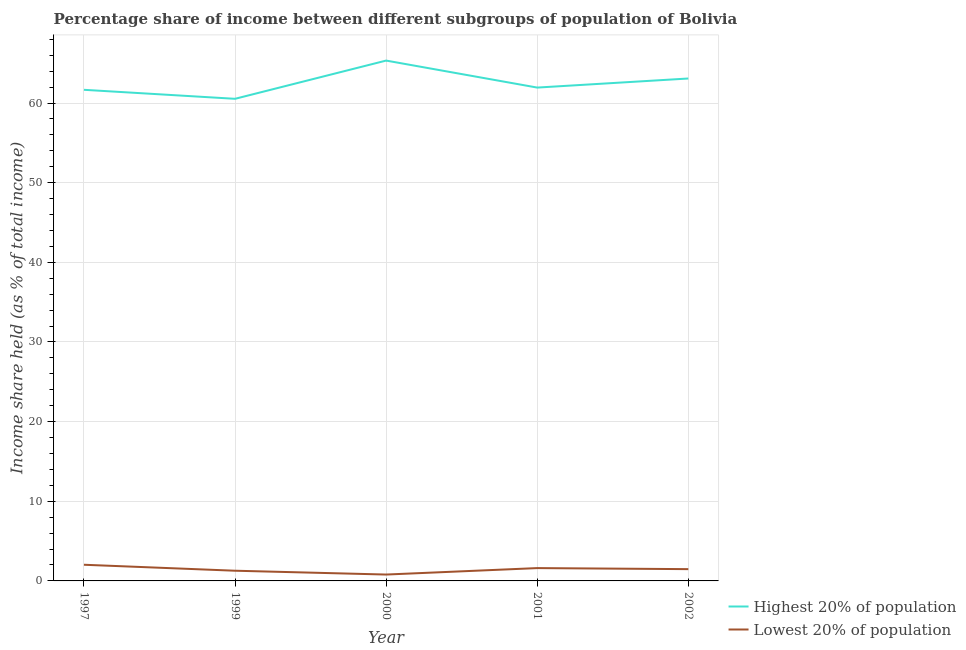How many different coloured lines are there?
Provide a succinct answer. 2. Is the number of lines equal to the number of legend labels?
Ensure brevity in your answer.  Yes. What is the income share held by lowest 20% of the population in 2002?
Keep it short and to the point. 1.48. Across all years, what is the maximum income share held by highest 20% of the population?
Make the answer very short. 65.33. In which year was the income share held by lowest 20% of the population maximum?
Provide a succinct answer. 1997. In which year was the income share held by highest 20% of the population minimum?
Ensure brevity in your answer.  1999. What is the total income share held by lowest 20% of the population in the graph?
Your answer should be compact. 7.2. What is the difference between the income share held by highest 20% of the population in 1997 and that in 1999?
Offer a very short reply. 1.13. What is the difference between the income share held by highest 20% of the population in 2001 and the income share held by lowest 20% of the population in 1999?
Offer a very short reply. 60.66. What is the average income share held by highest 20% of the population per year?
Your answer should be very brief. 62.51. In the year 1997, what is the difference between the income share held by lowest 20% of the population and income share held by highest 20% of the population?
Your answer should be very brief. -59.63. In how many years, is the income share held by highest 20% of the population greater than 56 %?
Ensure brevity in your answer.  5. What is the ratio of the income share held by highest 20% of the population in 2000 to that in 2001?
Your response must be concise. 1.05. Is the difference between the income share held by lowest 20% of the population in 1997 and 1999 greater than the difference between the income share held by highest 20% of the population in 1997 and 1999?
Ensure brevity in your answer.  No. What is the difference between the highest and the second highest income share held by highest 20% of the population?
Provide a short and direct response. 2.25. What is the difference between the highest and the lowest income share held by highest 20% of the population?
Your answer should be compact. 4.8. In how many years, is the income share held by highest 20% of the population greater than the average income share held by highest 20% of the population taken over all years?
Ensure brevity in your answer.  2. Does the income share held by lowest 20% of the population monotonically increase over the years?
Ensure brevity in your answer.  No. Are the values on the major ticks of Y-axis written in scientific E-notation?
Make the answer very short. No. Where does the legend appear in the graph?
Your response must be concise. Bottom right. How are the legend labels stacked?
Make the answer very short. Vertical. What is the title of the graph?
Keep it short and to the point. Percentage share of income between different subgroups of population of Bolivia. Does "Time to export" appear as one of the legend labels in the graph?
Your answer should be compact. No. What is the label or title of the Y-axis?
Offer a terse response. Income share held (as % of total income). What is the Income share held (as % of total income) in Highest 20% of population in 1997?
Give a very brief answer. 61.66. What is the Income share held (as % of total income) in Lowest 20% of population in 1997?
Make the answer very short. 2.03. What is the Income share held (as % of total income) of Highest 20% of population in 1999?
Provide a short and direct response. 60.53. What is the Income share held (as % of total income) of Lowest 20% of population in 1999?
Make the answer very short. 1.28. What is the Income share held (as % of total income) of Highest 20% of population in 2000?
Give a very brief answer. 65.33. What is the Income share held (as % of total income) of Lowest 20% of population in 2000?
Your answer should be compact. 0.8. What is the Income share held (as % of total income) in Highest 20% of population in 2001?
Provide a succinct answer. 61.94. What is the Income share held (as % of total income) of Lowest 20% of population in 2001?
Provide a succinct answer. 1.61. What is the Income share held (as % of total income) in Highest 20% of population in 2002?
Your answer should be compact. 63.08. What is the Income share held (as % of total income) of Lowest 20% of population in 2002?
Your response must be concise. 1.48. Across all years, what is the maximum Income share held (as % of total income) in Highest 20% of population?
Keep it short and to the point. 65.33. Across all years, what is the maximum Income share held (as % of total income) in Lowest 20% of population?
Your answer should be very brief. 2.03. Across all years, what is the minimum Income share held (as % of total income) of Highest 20% of population?
Provide a succinct answer. 60.53. What is the total Income share held (as % of total income) of Highest 20% of population in the graph?
Give a very brief answer. 312.54. What is the difference between the Income share held (as % of total income) in Highest 20% of population in 1997 and that in 1999?
Give a very brief answer. 1.13. What is the difference between the Income share held (as % of total income) in Lowest 20% of population in 1997 and that in 1999?
Offer a very short reply. 0.75. What is the difference between the Income share held (as % of total income) of Highest 20% of population in 1997 and that in 2000?
Provide a short and direct response. -3.67. What is the difference between the Income share held (as % of total income) in Lowest 20% of population in 1997 and that in 2000?
Your answer should be compact. 1.23. What is the difference between the Income share held (as % of total income) of Highest 20% of population in 1997 and that in 2001?
Your answer should be compact. -0.28. What is the difference between the Income share held (as % of total income) in Lowest 20% of population in 1997 and that in 2001?
Offer a terse response. 0.42. What is the difference between the Income share held (as % of total income) in Highest 20% of population in 1997 and that in 2002?
Provide a succinct answer. -1.42. What is the difference between the Income share held (as % of total income) of Lowest 20% of population in 1997 and that in 2002?
Your response must be concise. 0.55. What is the difference between the Income share held (as % of total income) in Highest 20% of population in 1999 and that in 2000?
Keep it short and to the point. -4.8. What is the difference between the Income share held (as % of total income) in Lowest 20% of population in 1999 and that in 2000?
Your answer should be very brief. 0.48. What is the difference between the Income share held (as % of total income) in Highest 20% of population in 1999 and that in 2001?
Offer a very short reply. -1.41. What is the difference between the Income share held (as % of total income) in Lowest 20% of population in 1999 and that in 2001?
Your answer should be very brief. -0.33. What is the difference between the Income share held (as % of total income) in Highest 20% of population in 1999 and that in 2002?
Make the answer very short. -2.55. What is the difference between the Income share held (as % of total income) of Lowest 20% of population in 1999 and that in 2002?
Provide a short and direct response. -0.2. What is the difference between the Income share held (as % of total income) in Highest 20% of population in 2000 and that in 2001?
Offer a very short reply. 3.39. What is the difference between the Income share held (as % of total income) in Lowest 20% of population in 2000 and that in 2001?
Offer a very short reply. -0.81. What is the difference between the Income share held (as % of total income) in Highest 20% of population in 2000 and that in 2002?
Give a very brief answer. 2.25. What is the difference between the Income share held (as % of total income) in Lowest 20% of population in 2000 and that in 2002?
Your answer should be compact. -0.68. What is the difference between the Income share held (as % of total income) of Highest 20% of population in 2001 and that in 2002?
Your response must be concise. -1.14. What is the difference between the Income share held (as % of total income) in Lowest 20% of population in 2001 and that in 2002?
Your response must be concise. 0.13. What is the difference between the Income share held (as % of total income) in Highest 20% of population in 1997 and the Income share held (as % of total income) in Lowest 20% of population in 1999?
Your response must be concise. 60.38. What is the difference between the Income share held (as % of total income) in Highest 20% of population in 1997 and the Income share held (as % of total income) in Lowest 20% of population in 2000?
Make the answer very short. 60.86. What is the difference between the Income share held (as % of total income) in Highest 20% of population in 1997 and the Income share held (as % of total income) in Lowest 20% of population in 2001?
Your answer should be compact. 60.05. What is the difference between the Income share held (as % of total income) of Highest 20% of population in 1997 and the Income share held (as % of total income) of Lowest 20% of population in 2002?
Your response must be concise. 60.18. What is the difference between the Income share held (as % of total income) in Highest 20% of population in 1999 and the Income share held (as % of total income) in Lowest 20% of population in 2000?
Provide a short and direct response. 59.73. What is the difference between the Income share held (as % of total income) of Highest 20% of population in 1999 and the Income share held (as % of total income) of Lowest 20% of population in 2001?
Provide a short and direct response. 58.92. What is the difference between the Income share held (as % of total income) in Highest 20% of population in 1999 and the Income share held (as % of total income) in Lowest 20% of population in 2002?
Ensure brevity in your answer.  59.05. What is the difference between the Income share held (as % of total income) of Highest 20% of population in 2000 and the Income share held (as % of total income) of Lowest 20% of population in 2001?
Offer a terse response. 63.72. What is the difference between the Income share held (as % of total income) in Highest 20% of population in 2000 and the Income share held (as % of total income) in Lowest 20% of population in 2002?
Your answer should be very brief. 63.85. What is the difference between the Income share held (as % of total income) of Highest 20% of population in 2001 and the Income share held (as % of total income) of Lowest 20% of population in 2002?
Give a very brief answer. 60.46. What is the average Income share held (as % of total income) of Highest 20% of population per year?
Give a very brief answer. 62.51. What is the average Income share held (as % of total income) in Lowest 20% of population per year?
Give a very brief answer. 1.44. In the year 1997, what is the difference between the Income share held (as % of total income) of Highest 20% of population and Income share held (as % of total income) of Lowest 20% of population?
Keep it short and to the point. 59.63. In the year 1999, what is the difference between the Income share held (as % of total income) of Highest 20% of population and Income share held (as % of total income) of Lowest 20% of population?
Give a very brief answer. 59.25. In the year 2000, what is the difference between the Income share held (as % of total income) of Highest 20% of population and Income share held (as % of total income) of Lowest 20% of population?
Offer a terse response. 64.53. In the year 2001, what is the difference between the Income share held (as % of total income) in Highest 20% of population and Income share held (as % of total income) in Lowest 20% of population?
Provide a short and direct response. 60.33. In the year 2002, what is the difference between the Income share held (as % of total income) of Highest 20% of population and Income share held (as % of total income) of Lowest 20% of population?
Offer a terse response. 61.6. What is the ratio of the Income share held (as % of total income) of Highest 20% of population in 1997 to that in 1999?
Give a very brief answer. 1.02. What is the ratio of the Income share held (as % of total income) in Lowest 20% of population in 1997 to that in 1999?
Your answer should be compact. 1.59. What is the ratio of the Income share held (as % of total income) in Highest 20% of population in 1997 to that in 2000?
Provide a short and direct response. 0.94. What is the ratio of the Income share held (as % of total income) of Lowest 20% of population in 1997 to that in 2000?
Offer a terse response. 2.54. What is the ratio of the Income share held (as % of total income) of Highest 20% of population in 1997 to that in 2001?
Provide a succinct answer. 1. What is the ratio of the Income share held (as % of total income) in Lowest 20% of population in 1997 to that in 2001?
Offer a very short reply. 1.26. What is the ratio of the Income share held (as % of total income) of Highest 20% of population in 1997 to that in 2002?
Ensure brevity in your answer.  0.98. What is the ratio of the Income share held (as % of total income) of Lowest 20% of population in 1997 to that in 2002?
Your answer should be compact. 1.37. What is the ratio of the Income share held (as % of total income) of Highest 20% of population in 1999 to that in 2000?
Your answer should be compact. 0.93. What is the ratio of the Income share held (as % of total income) of Highest 20% of population in 1999 to that in 2001?
Offer a very short reply. 0.98. What is the ratio of the Income share held (as % of total income) of Lowest 20% of population in 1999 to that in 2001?
Provide a succinct answer. 0.8. What is the ratio of the Income share held (as % of total income) of Highest 20% of population in 1999 to that in 2002?
Keep it short and to the point. 0.96. What is the ratio of the Income share held (as % of total income) in Lowest 20% of population in 1999 to that in 2002?
Provide a succinct answer. 0.86. What is the ratio of the Income share held (as % of total income) in Highest 20% of population in 2000 to that in 2001?
Your answer should be very brief. 1.05. What is the ratio of the Income share held (as % of total income) in Lowest 20% of population in 2000 to that in 2001?
Give a very brief answer. 0.5. What is the ratio of the Income share held (as % of total income) in Highest 20% of population in 2000 to that in 2002?
Keep it short and to the point. 1.04. What is the ratio of the Income share held (as % of total income) in Lowest 20% of population in 2000 to that in 2002?
Offer a terse response. 0.54. What is the ratio of the Income share held (as % of total income) of Highest 20% of population in 2001 to that in 2002?
Make the answer very short. 0.98. What is the ratio of the Income share held (as % of total income) in Lowest 20% of population in 2001 to that in 2002?
Provide a short and direct response. 1.09. What is the difference between the highest and the second highest Income share held (as % of total income) in Highest 20% of population?
Make the answer very short. 2.25. What is the difference between the highest and the second highest Income share held (as % of total income) of Lowest 20% of population?
Offer a terse response. 0.42. What is the difference between the highest and the lowest Income share held (as % of total income) of Highest 20% of population?
Your answer should be very brief. 4.8. What is the difference between the highest and the lowest Income share held (as % of total income) of Lowest 20% of population?
Your response must be concise. 1.23. 